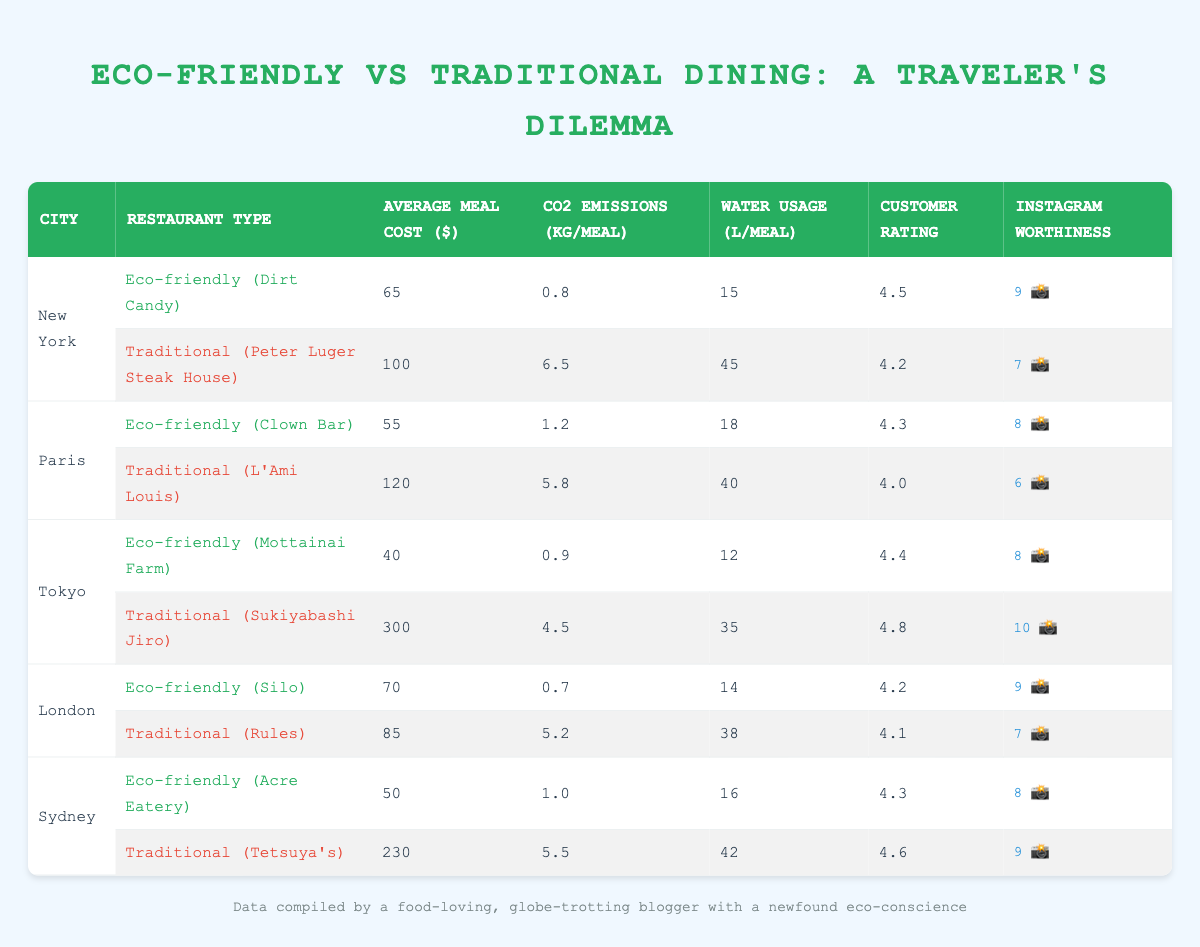What's the average meal cost for eco-friendly restaurants in New York? From the table, the eco-friendly restaurant in New York is Dirt Candy, which has an average meal cost of $65. Therefore, the average meal cost for eco-friendly restaurants in New York is $65.
Answer: 65 Which traditional restaurant in Sydney has the highest customer rating? The traditional restaurant in Sydney is Tetsuya's, which has a customer rating of 4.6. As there is only one traditional restaurant in Sydney, Tetsuya's holds the highest rating.
Answer: Tetsuya's What is the total CO2 emissions per meal for traditional restaurants in Paris and London combined? For traditional restaurants in Paris (L'Ami Louis) and London (Rules), the CO2 emissions per meal are 5.8 kg and 5.2 kg, respectively. Adding these gives 5.8 + 5.2 = 11 kg.
Answer: 11 Is the Instagram worthiness of eco-friendly dining options generally higher than traditional ones? Comparing the Instagram worthiness scores, Dirt Candy (9), Clown Bar (8), Mottainai Farm (8), Silo (9), and Acre Eatery (8) gives an average of 8.4 for eco-friendly, while for traditional options, Peter Luger (7), L'Ami Louis (6), Sukiyabashi Jiro (10), Rules (7), and Tetsuya's (9) gives an average of 7.8. Since 8.4 > 7.8, eco-friendly dining options are generally more Instagram worthy.
Answer: Yes What is the difference in average meal cost between the eco-friendly and traditional dining options in Tokyo? The average meal cost for the eco-friendly restaurant (Mottainai Farm) is $40, and for the traditional restaurant (Sukiyabashi Jiro), it is $300. The difference is 300 - 40 = 260.
Answer: 260 